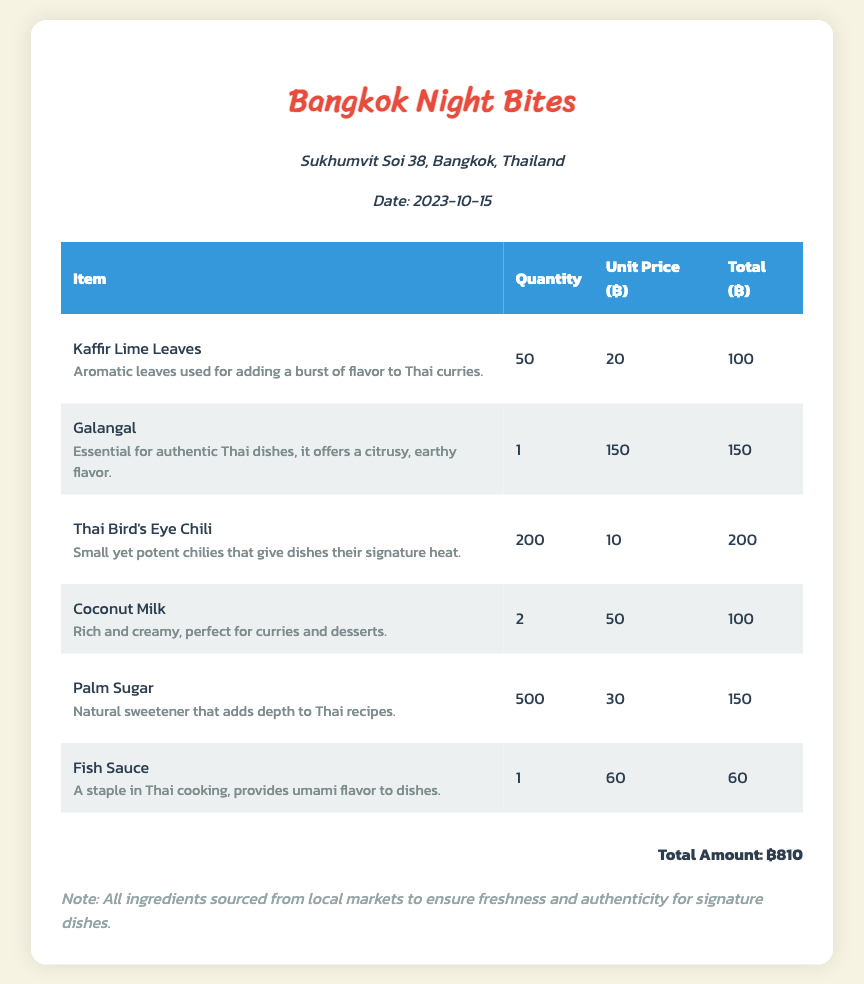What is the date of the transaction? The date of the transaction is provided in the vendor info section of the document.
Answer: 2023-10-15 What is the total amount spent? The total amount is calculated from the total of all items purchased listed in the document.
Answer: ฿810 How many Kaffir Lime Leaves were purchased? This is specified in the quantity column for Kaffir Lime Leaves in the table.
Answer: 50 What is the unit price of Galangal? The unit price is listed in the table under the relevant item.
Answer: 150 What type of chili is mentioned in the receipt? The type of chili is specified in the item name within the table.
Answer: Thai Bird's Eye Chili How much Palm Sugar was bought? The quantity of Palm Sugar is clearly indicated in the quantity column of the table.
Answer: 500 What is the description of Fish Sauce? The description of Fish Sauce is provided directly below the item name in the table.
Answer: A staple in Thai cooking, provides umami flavor to dishes What can Coconut Milk be used for according to the description? The use of Coconut Milk is stated in the description column of the table.
Answer: Curries and desserts Why are the ingredients sourced from local markets? The note at the bottom of the document explains the reasoning for sourcing.
Answer: Freshness and authenticity for signature dishes 